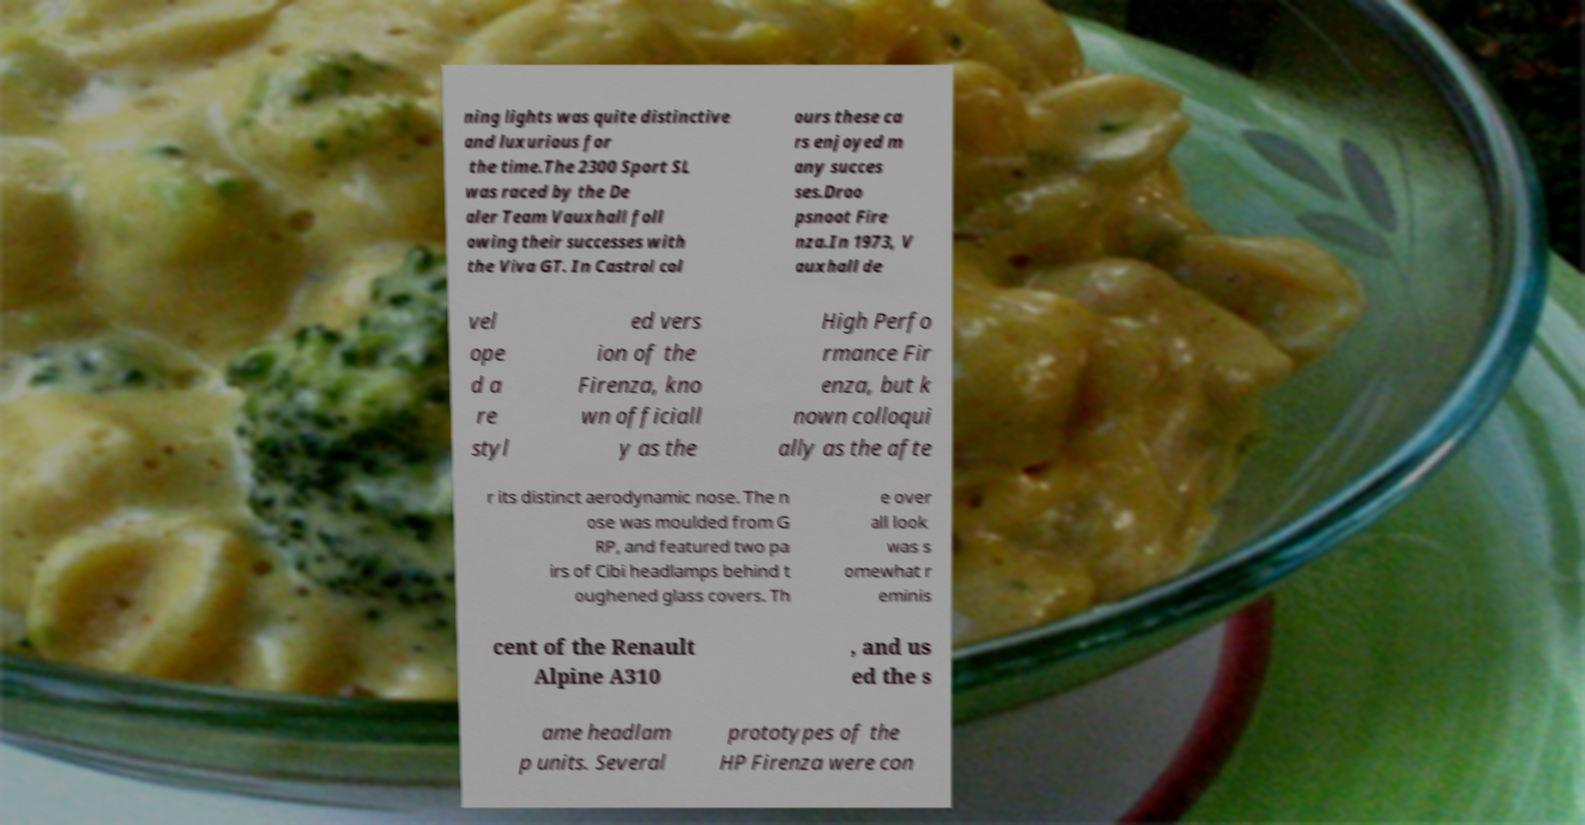What messages or text are displayed in this image? I need them in a readable, typed format. ning lights was quite distinctive and luxurious for the time.The 2300 Sport SL was raced by the De aler Team Vauxhall foll owing their successes with the Viva GT. In Castrol col ours these ca rs enjoyed m any succes ses.Droo psnoot Fire nza.In 1973, V auxhall de vel ope d a re styl ed vers ion of the Firenza, kno wn officiall y as the High Perfo rmance Fir enza, but k nown colloqui ally as the afte r its distinct aerodynamic nose. The n ose was moulded from G RP, and featured two pa irs of Cibi headlamps behind t oughened glass covers. Th e over all look was s omewhat r eminis cent of the Renault Alpine A310 , and us ed the s ame headlam p units. Several prototypes of the HP Firenza were con 